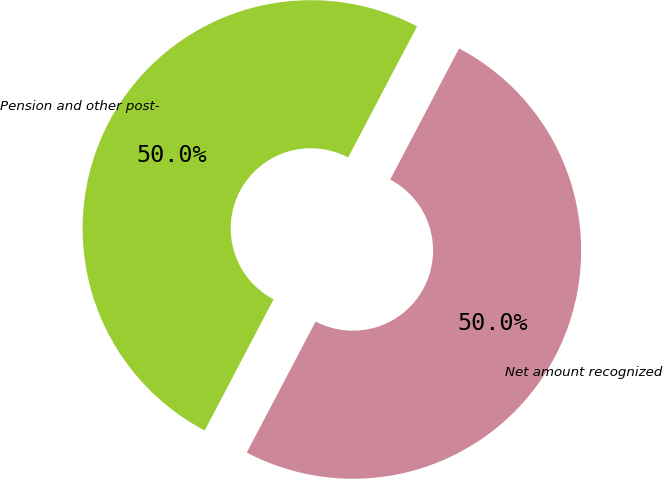Convert chart. <chart><loc_0><loc_0><loc_500><loc_500><pie_chart><fcel>Pension and other post-<fcel>Net amount recognized<nl><fcel>50.0%<fcel>50.0%<nl></chart> 